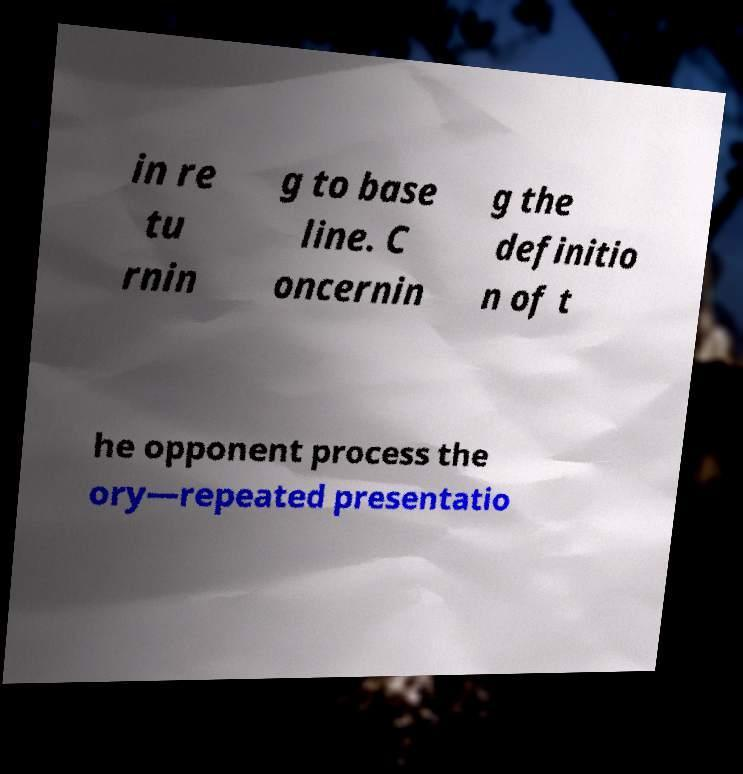I need the written content from this picture converted into text. Can you do that? in re tu rnin g to base line. C oncernin g the definitio n of t he opponent process the ory—repeated presentatio 